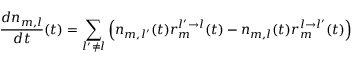<formula> <loc_0><loc_0><loc_500><loc_500>\frac { d n _ { m , l } } { d t } ( t ) = \sum _ { l ^ { \prime } \neq l } \left ( n _ { m , l ^ { \prime } } ( t ) r _ { m } ^ { l ^ { \prime } \rightarrow l } ( t ) - n _ { m , l } ( t ) r _ { m } ^ { l \rightarrow l ^ { \prime } } ( t ) \right )</formula> 